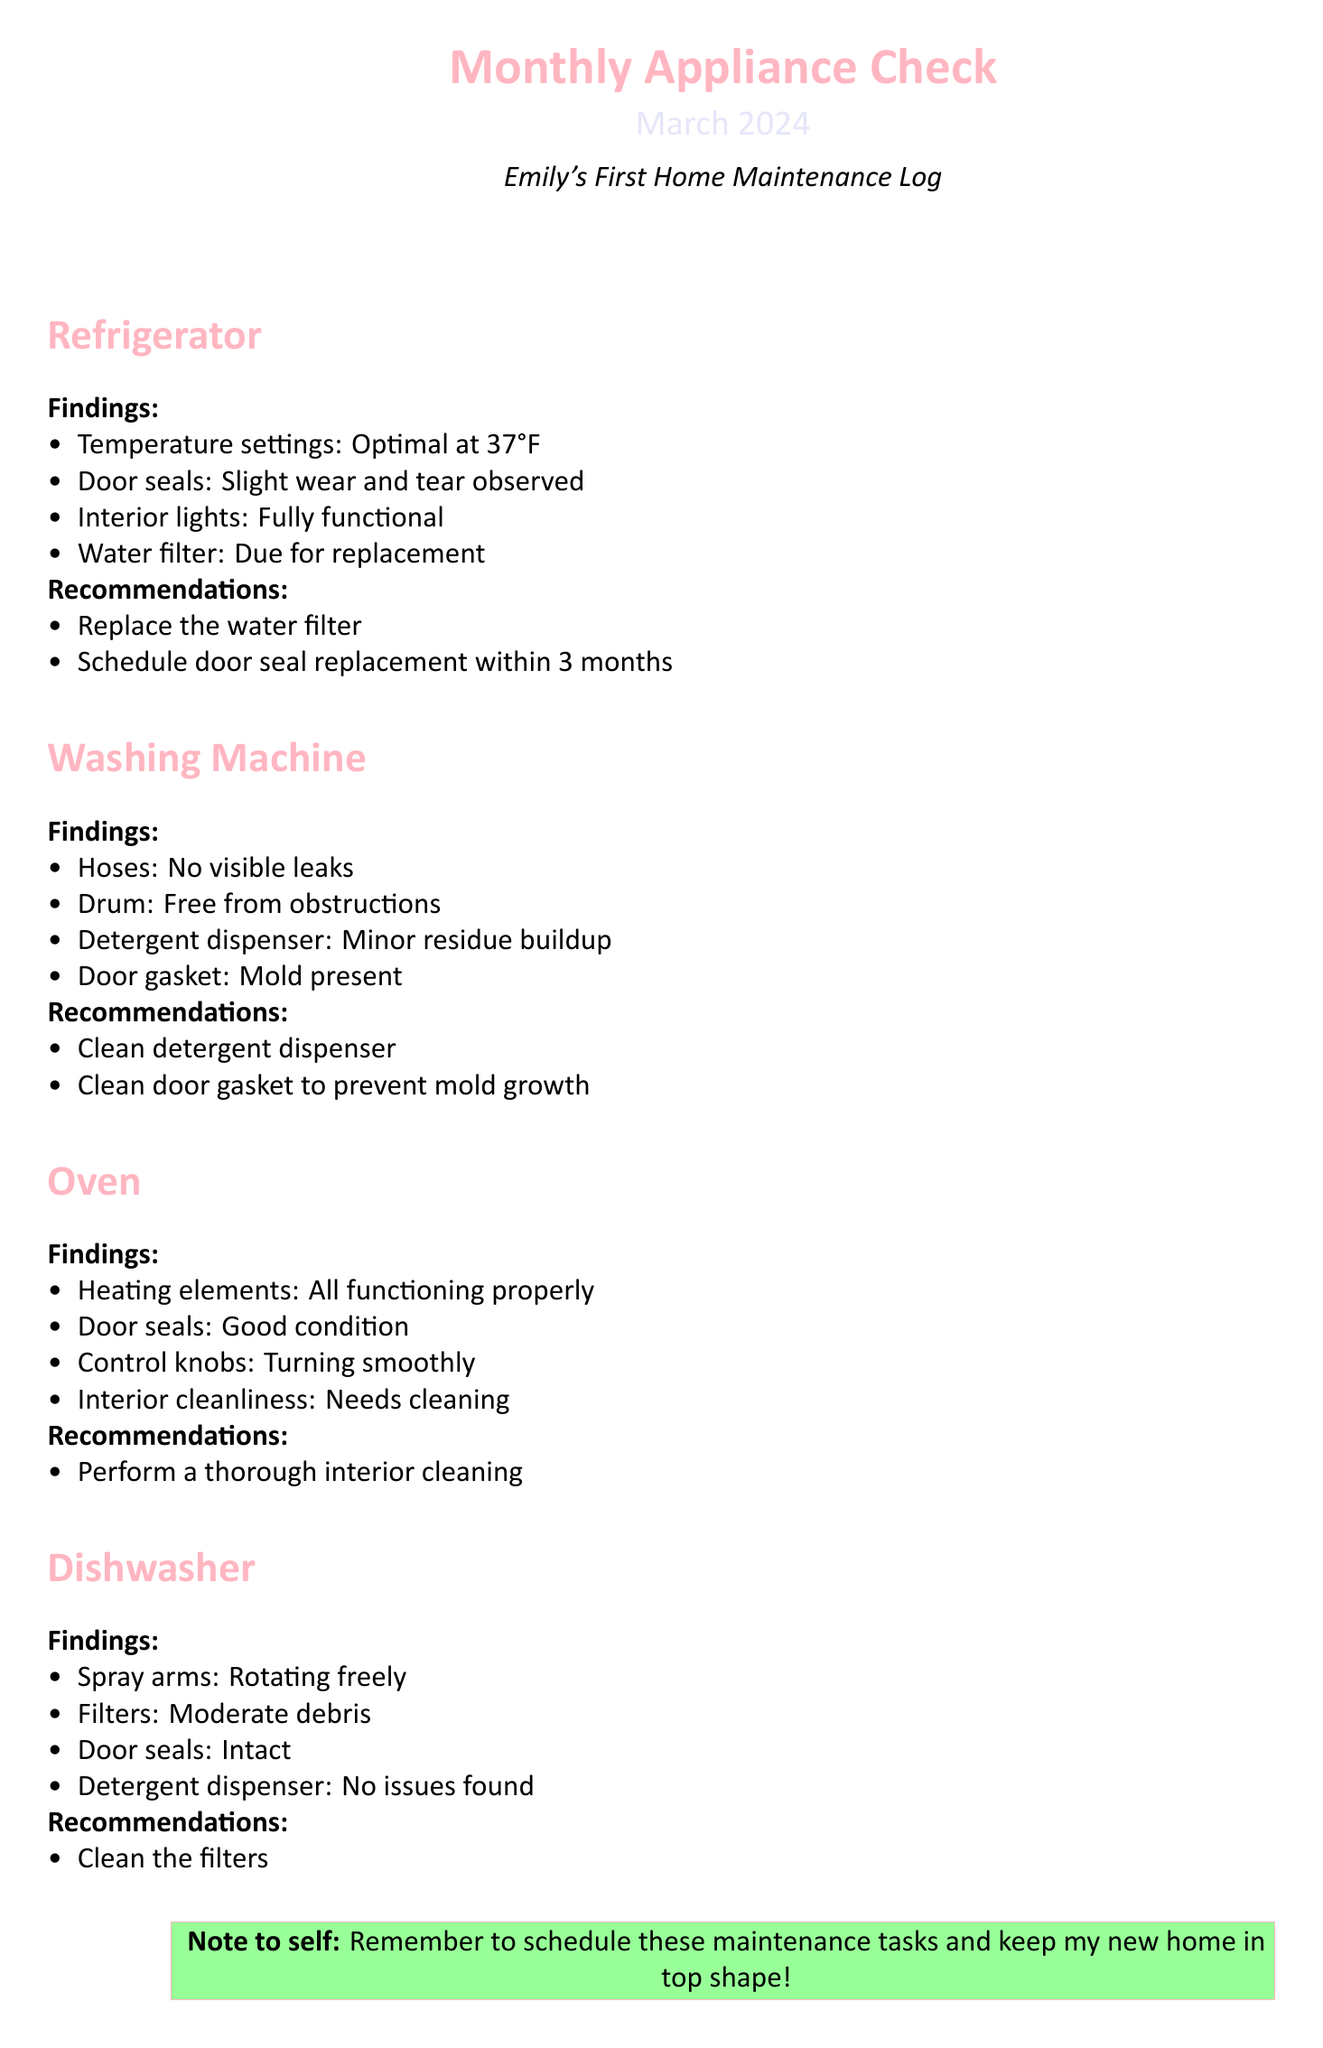What was the optimal temperature setting for the refrigerator? The optimal temperature setting for the refrigerator is provided in the findings section.
Answer: 37°F What maintenance task is due for the refrigerator? The document specifies the maintenance task due for the refrigerator in the recommendations section.
Answer: Replace the water filter When should the door seal replacement for the refrigerator be scheduled? The recommendation mentions a timeframe for scheduling the door seal replacement.
Answer: Within 3 months What type of residue was found in the washing machine's detergent dispenser? The document states the condition of the detergent dispenser, including the type of residue observed.
Answer: Minor residue buildup What is suggested to clean in the washing machine to prevent mold growth? The recommendations for the washing machine suggest a specific action to prevent mold.
Answer: Clean door gasket What maintenance task is recommended for the oven? The recommendations section for the oven lists a specific task that needs to be performed.
Answer: Perform a thorough interior cleaning What condition were the dishwasher door seals reported to be in? The findings for the dishwasher include the status of the door seals.
Answer: Intact What should be cleaned in the dishwasher? The recommendations state a specific component that needs cleaning in the dishwasher.
Answer: Clean the filters 